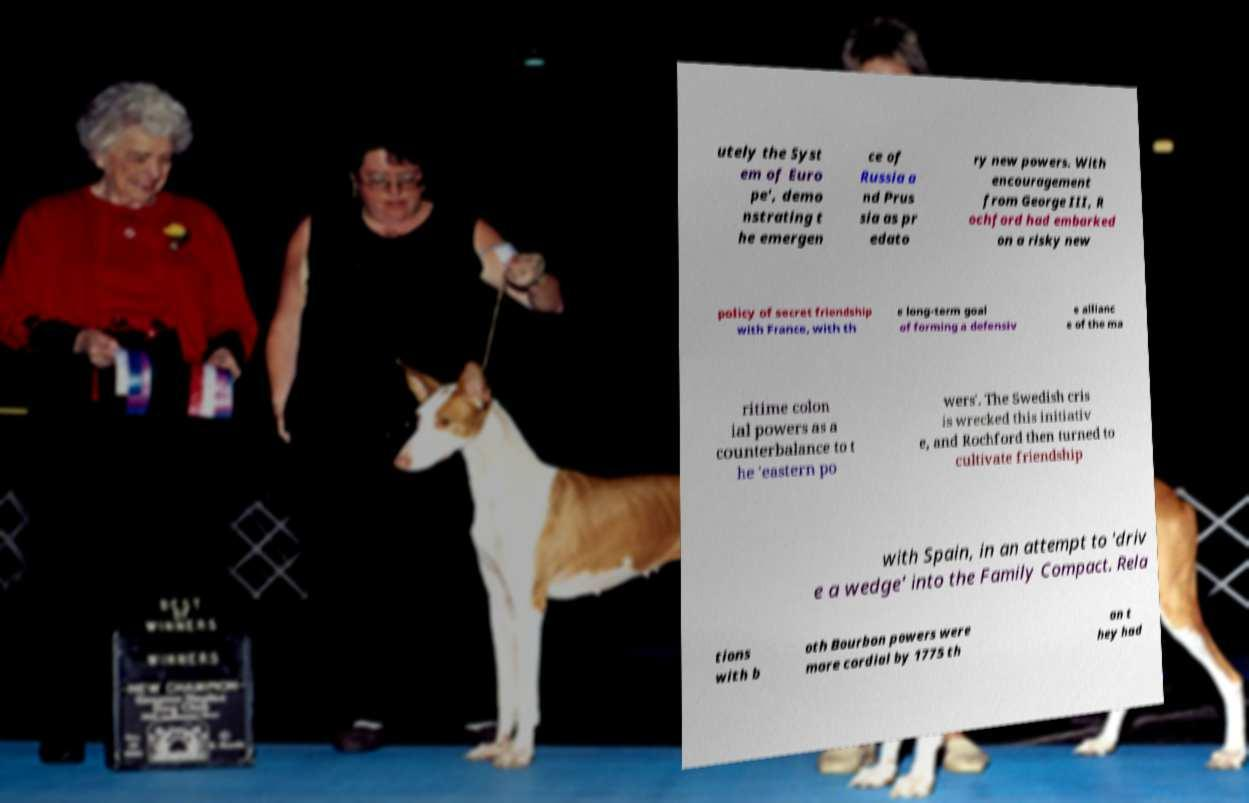Can you accurately transcribe the text from the provided image for me? utely the Syst em of Euro pe', demo nstrating t he emergen ce of Russia a nd Prus sia as pr edato ry new powers. With encouragement from George III, R ochford had embarked on a risky new policy of secret friendship with France, with th e long-term goal of forming a defensiv e allianc e of the ma ritime colon ial powers as a counterbalance to t he 'eastern po wers'. The Swedish cris is wrecked this initiativ e, and Rochford then turned to cultivate friendship with Spain, in an attempt to 'driv e a wedge' into the Family Compact. Rela tions with b oth Bourbon powers were more cordial by 1775 th an t hey had 